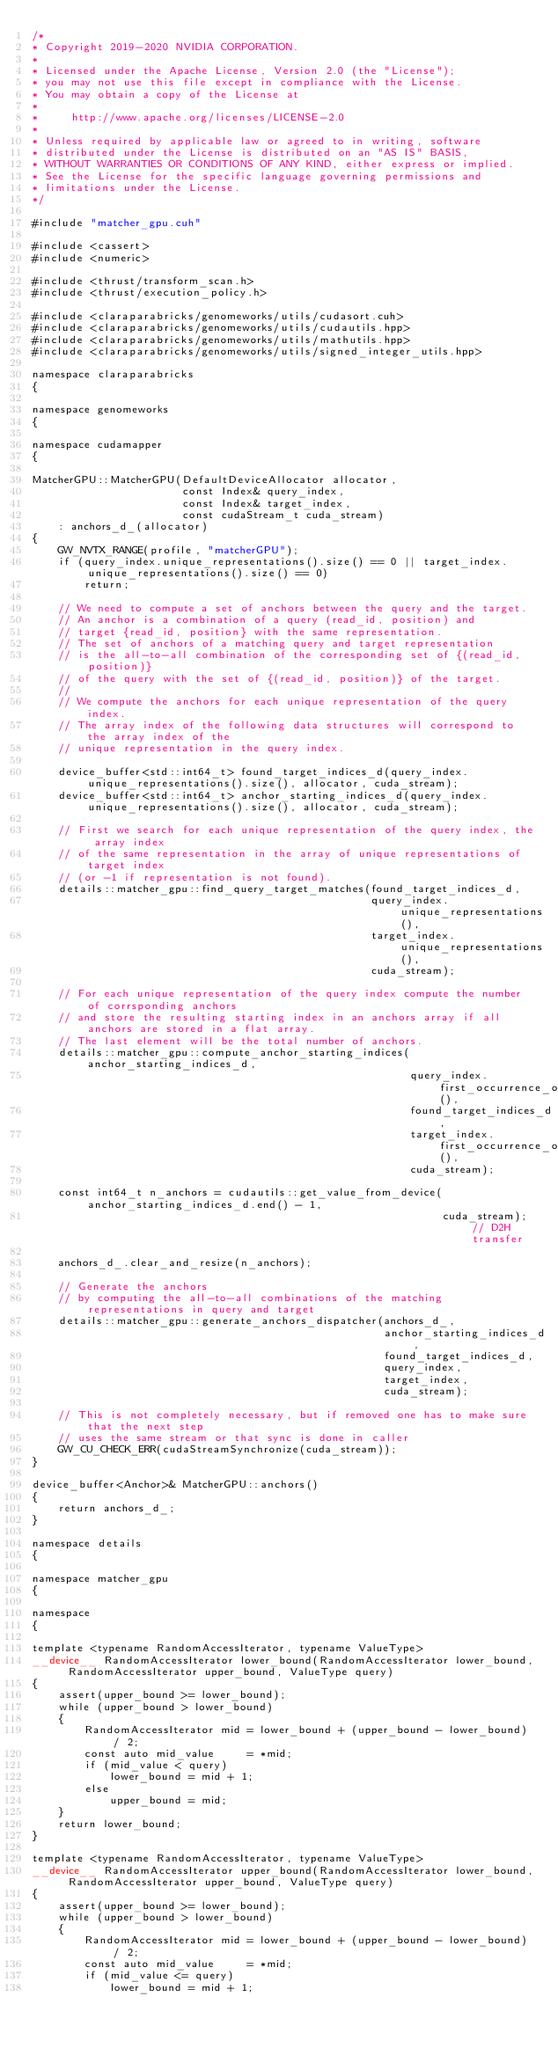<code> <loc_0><loc_0><loc_500><loc_500><_Cuda_>/*
* Copyright 2019-2020 NVIDIA CORPORATION.
*
* Licensed under the Apache License, Version 2.0 (the "License");
* you may not use this file except in compliance with the License.
* You may obtain a copy of the License at
*
*     http://www.apache.org/licenses/LICENSE-2.0
*
* Unless required by applicable law or agreed to in writing, software
* distributed under the License is distributed on an "AS IS" BASIS,
* WITHOUT WARRANTIES OR CONDITIONS OF ANY KIND, either express or implied.
* See the License for the specific language governing permissions and
* limitations under the License.
*/

#include "matcher_gpu.cuh"

#include <cassert>
#include <numeric>

#include <thrust/transform_scan.h>
#include <thrust/execution_policy.h>

#include <claraparabricks/genomeworks/utils/cudasort.cuh>
#include <claraparabricks/genomeworks/utils/cudautils.hpp>
#include <claraparabricks/genomeworks/utils/mathutils.hpp>
#include <claraparabricks/genomeworks/utils/signed_integer_utils.hpp>

namespace claraparabricks
{

namespace genomeworks
{

namespace cudamapper
{

MatcherGPU::MatcherGPU(DefaultDeviceAllocator allocator,
                       const Index& query_index,
                       const Index& target_index,
                       const cudaStream_t cuda_stream)
    : anchors_d_(allocator)
{
    GW_NVTX_RANGE(profile, "matcherGPU");
    if (query_index.unique_representations().size() == 0 || target_index.unique_representations().size() == 0)
        return;

    // We need to compute a set of anchors between the query and the target.
    // An anchor is a combination of a query (read_id, position) and
    // target {read_id, position} with the same representation.
    // The set of anchors of a matching query and target representation
    // is the all-to-all combination of the corresponding set of {(read_id, position)}
    // of the query with the set of {(read_id, position)} of the target.
    //
    // We compute the anchors for each unique representation of the query index.
    // The array index of the following data structures will correspond to the array index of the
    // unique representation in the query index.

    device_buffer<std::int64_t> found_target_indices_d(query_index.unique_representations().size(), allocator, cuda_stream);
    device_buffer<std::int64_t> anchor_starting_indices_d(query_index.unique_representations().size(), allocator, cuda_stream);

    // First we search for each unique representation of the query index, the array index
    // of the same representation in the array of unique representations of target index
    // (or -1 if representation is not found).
    details::matcher_gpu::find_query_target_matches(found_target_indices_d,
                                                    query_index.unique_representations(),
                                                    target_index.unique_representations(),
                                                    cuda_stream);

    // For each unique representation of the query index compute the number of corrsponding anchors
    // and store the resulting starting index in an anchors array if all anchors are stored in a flat array.
    // The last element will be the total number of anchors.
    details::matcher_gpu::compute_anchor_starting_indices(anchor_starting_indices_d,
                                                          query_index.first_occurrence_of_representations(),
                                                          found_target_indices_d,
                                                          target_index.first_occurrence_of_representations(),
                                                          cuda_stream);

    const int64_t n_anchors = cudautils::get_value_from_device(anchor_starting_indices_d.end() - 1,
                                                               cuda_stream); // D2H transfer

    anchors_d_.clear_and_resize(n_anchors);

    // Generate the anchors
    // by computing the all-to-all combinations of the matching representations in query and target
    details::matcher_gpu::generate_anchors_dispatcher(anchors_d_,
                                                      anchor_starting_indices_d,
                                                      found_target_indices_d,
                                                      query_index,
                                                      target_index,
                                                      cuda_stream);

    // This is not completely necessary, but if removed one has to make sure that the next step
    // uses the same stream or that sync is done in caller
    GW_CU_CHECK_ERR(cudaStreamSynchronize(cuda_stream));
}

device_buffer<Anchor>& MatcherGPU::anchors()
{
    return anchors_d_;
}

namespace details
{

namespace matcher_gpu
{

namespace
{

template <typename RandomAccessIterator, typename ValueType>
__device__ RandomAccessIterator lower_bound(RandomAccessIterator lower_bound, RandomAccessIterator upper_bound, ValueType query)
{
    assert(upper_bound >= lower_bound);
    while (upper_bound > lower_bound)
    {
        RandomAccessIterator mid = lower_bound + (upper_bound - lower_bound) / 2;
        const auto mid_value     = *mid;
        if (mid_value < query)
            lower_bound = mid + 1;
        else
            upper_bound = mid;
    }
    return lower_bound;
}

template <typename RandomAccessIterator, typename ValueType>
__device__ RandomAccessIterator upper_bound(RandomAccessIterator lower_bound, RandomAccessIterator upper_bound, ValueType query)
{
    assert(upper_bound >= lower_bound);
    while (upper_bound > lower_bound)
    {
        RandomAccessIterator mid = lower_bound + (upper_bound - lower_bound) / 2;
        const auto mid_value     = *mid;
        if (mid_value <= query)
            lower_bound = mid + 1;</code> 